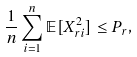<formula> <loc_0><loc_0><loc_500><loc_500>\frac { 1 } { n } \sum _ { i = 1 } ^ { n } \mathbb { E } [ X _ { r i } ^ { 2 } ] \leq P _ { r } ,</formula> 